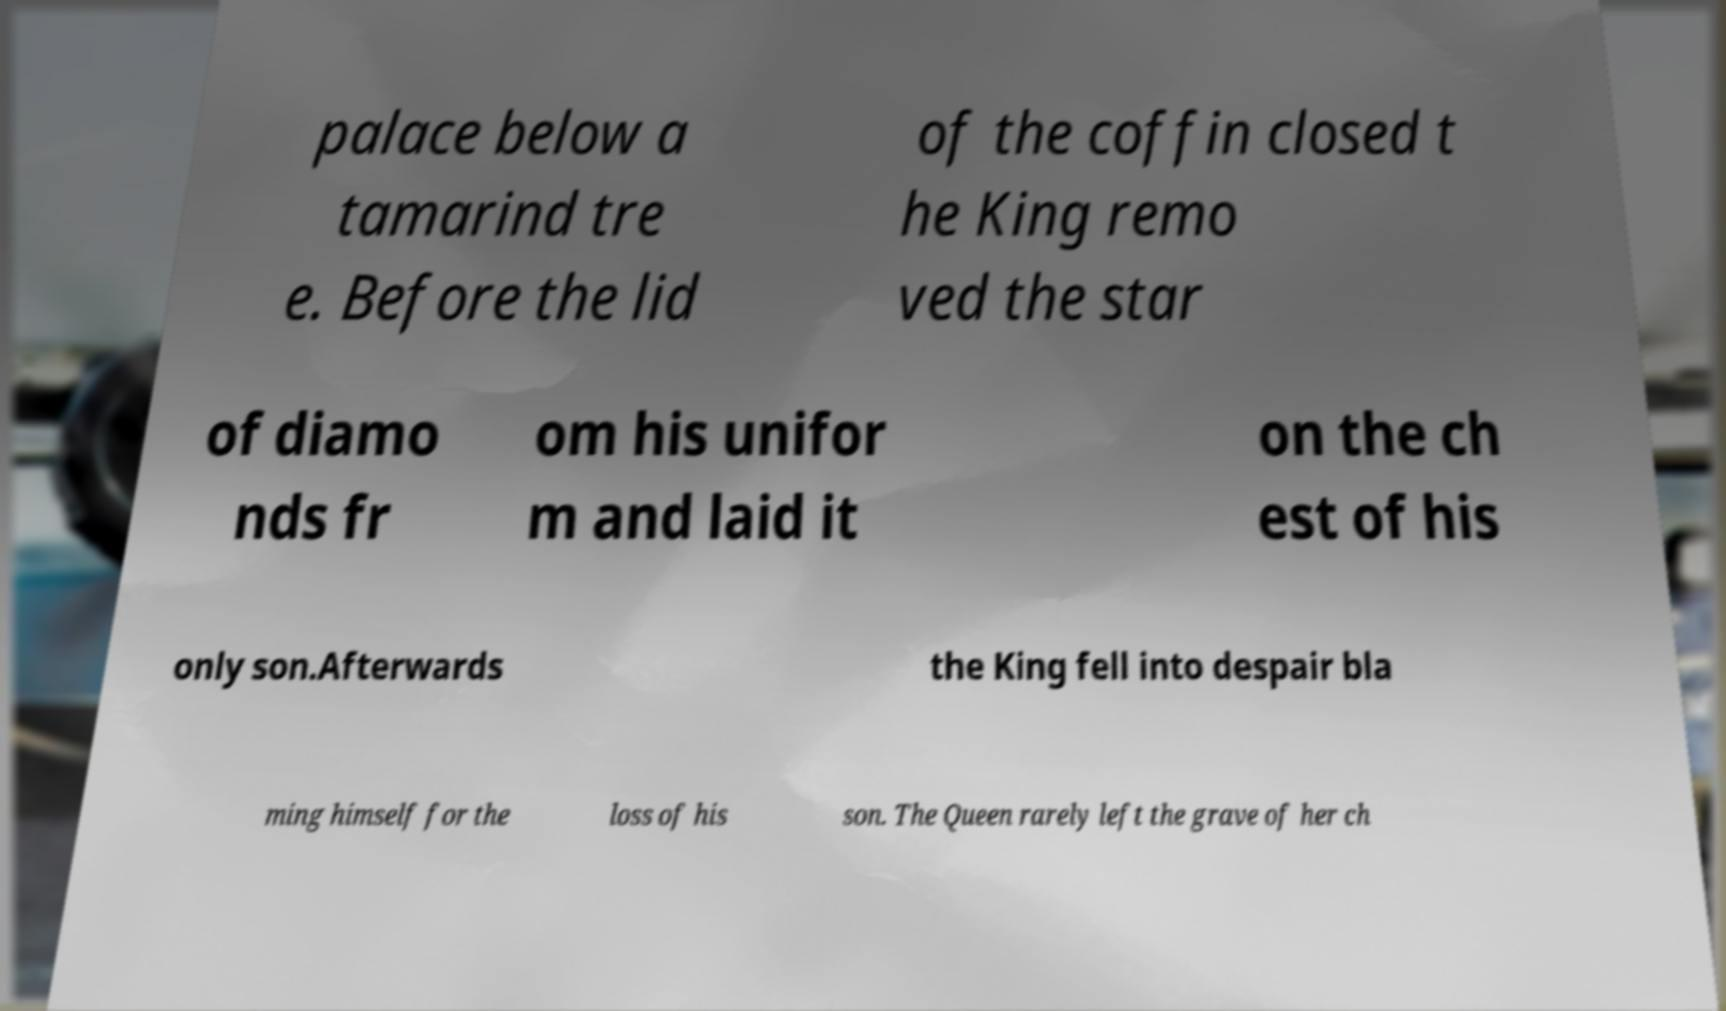Can you read and provide the text displayed in the image?This photo seems to have some interesting text. Can you extract and type it out for me? palace below a tamarind tre e. Before the lid of the coffin closed t he King remo ved the star of diamo nds fr om his unifor m and laid it on the ch est of his only son.Afterwards the King fell into despair bla ming himself for the loss of his son. The Queen rarely left the grave of her ch 